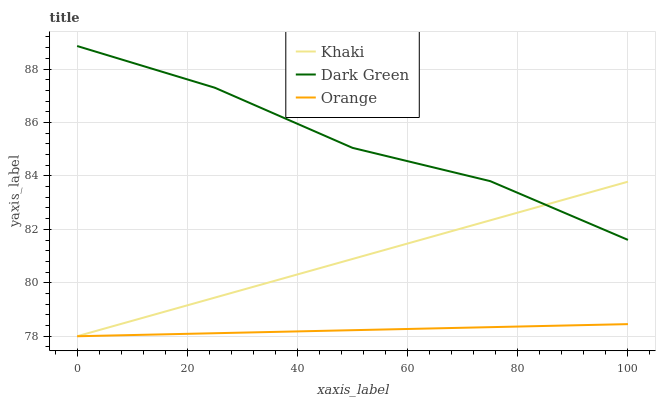Does Orange have the minimum area under the curve?
Answer yes or no. Yes. Does Dark Green have the maximum area under the curve?
Answer yes or no. Yes. Does Khaki have the minimum area under the curve?
Answer yes or no. No. Does Khaki have the maximum area under the curve?
Answer yes or no. No. Is Orange the smoothest?
Answer yes or no. Yes. Is Dark Green the roughest?
Answer yes or no. Yes. Is Khaki the smoothest?
Answer yes or no. No. Is Khaki the roughest?
Answer yes or no. No. Does Orange have the lowest value?
Answer yes or no. Yes. Does Dark Green have the lowest value?
Answer yes or no. No. Does Dark Green have the highest value?
Answer yes or no. Yes. Does Khaki have the highest value?
Answer yes or no. No. Is Orange less than Dark Green?
Answer yes or no. Yes. Is Dark Green greater than Orange?
Answer yes or no. Yes. Does Dark Green intersect Khaki?
Answer yes or no. Yes. Is Dark Green less than Khaki?
Answer yes or no. No. Is Dark Green greater than Khaki?
Answer yes or no. No. Does Orange intersect Dark Green?
Answer yes or no. No. 